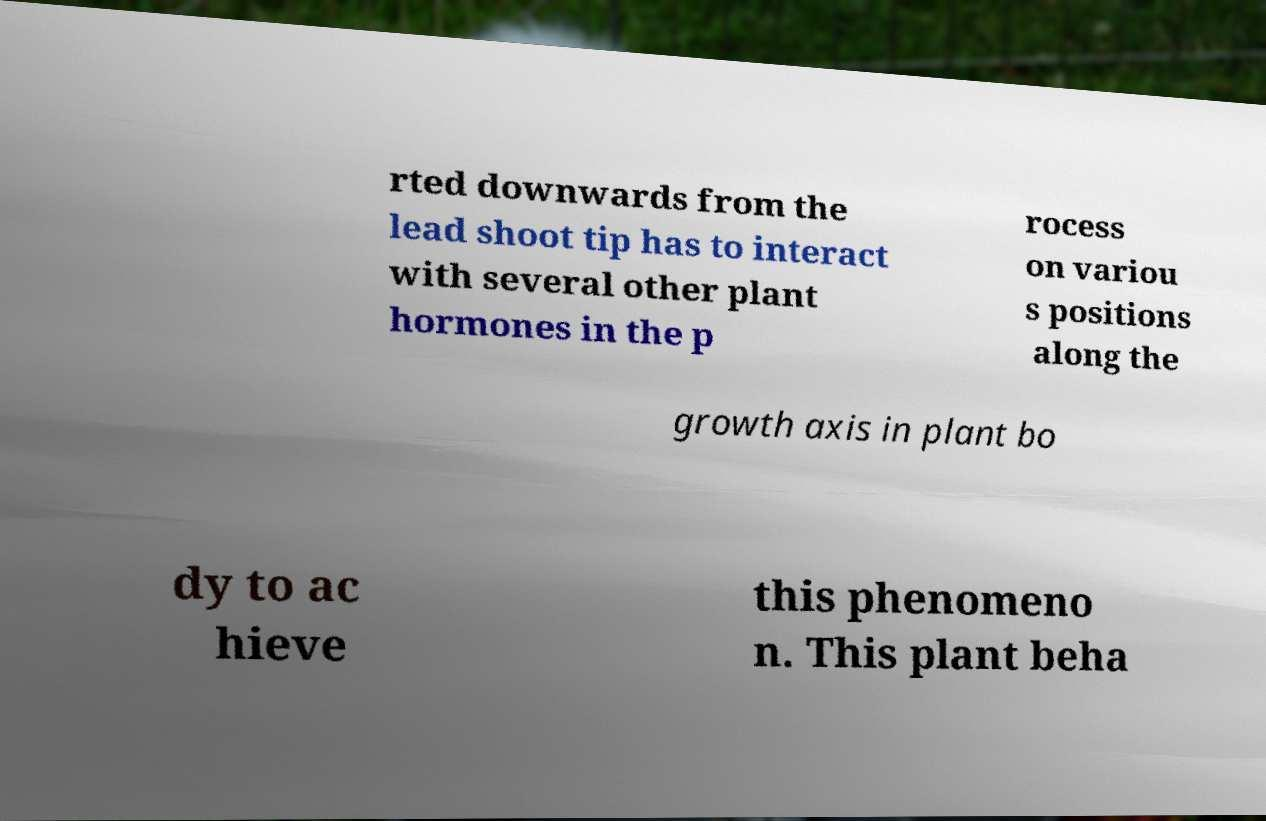For documentation purposes, I need the text within this image transcribed. Could you provide that? rted downwards from the lead shoot tip has to interact with several other plant hormones in the p rocess on variou s positions along the growth axis in plant bo dy to ac hieve this phenomeno n. This plant beha 